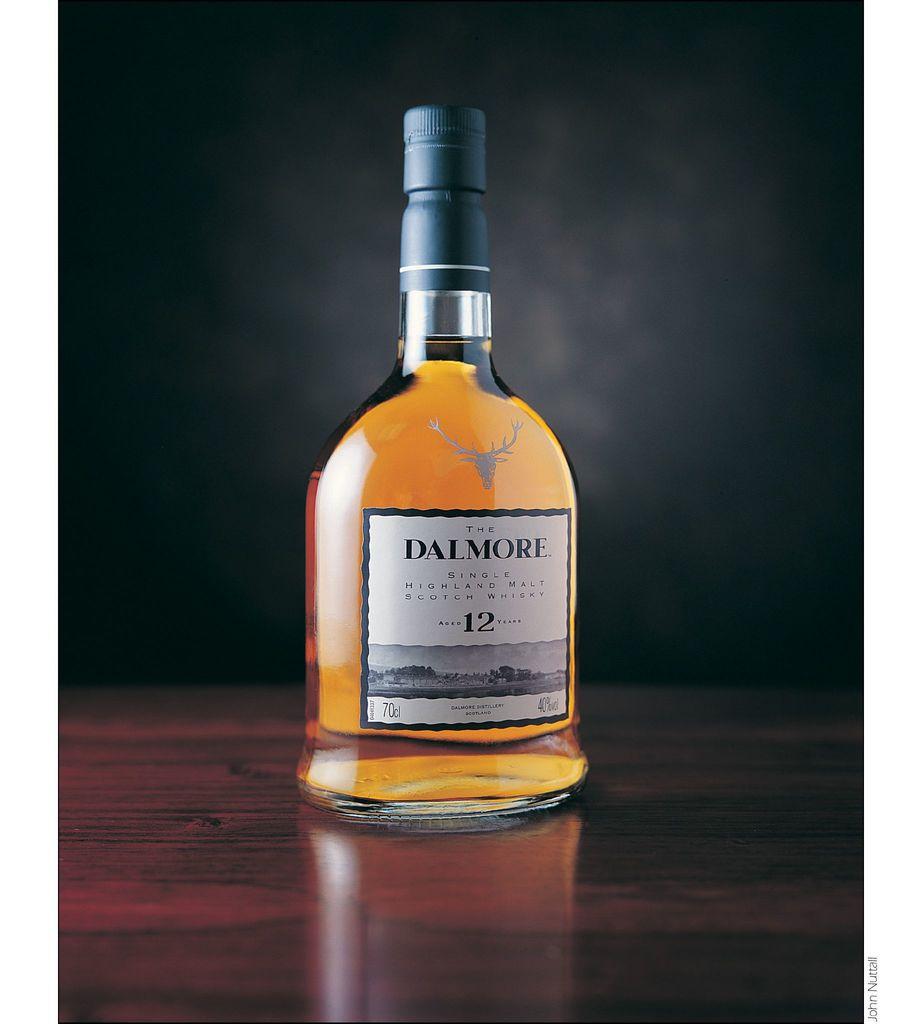What brand of alcohol is this?
Your answer should be compact. Dalmore. 